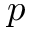<formula> <loc_0><loc_0><loc_500><loc_500>p</formula> 